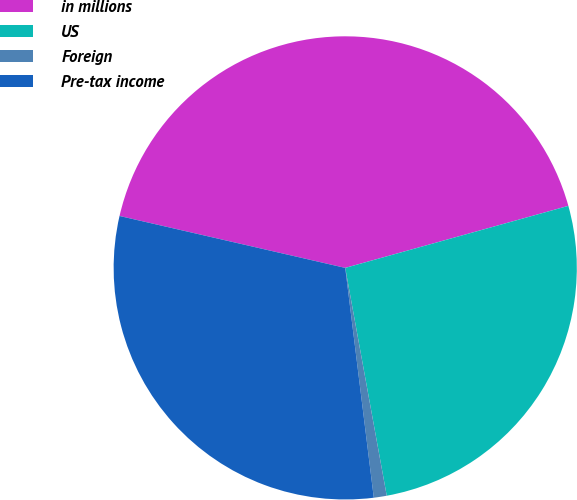Convert chart to OTSL. <chart><loc_0><loc_0><loc_500><loc_500><pie_chart><fcel>in millions<fcel>US<fcel>Foreign<fcel>Pre-tax income<nl><fcel>42.09%<fcel>26.45%<fcel>0.9%<fcel>30.57%<nl></chart> 